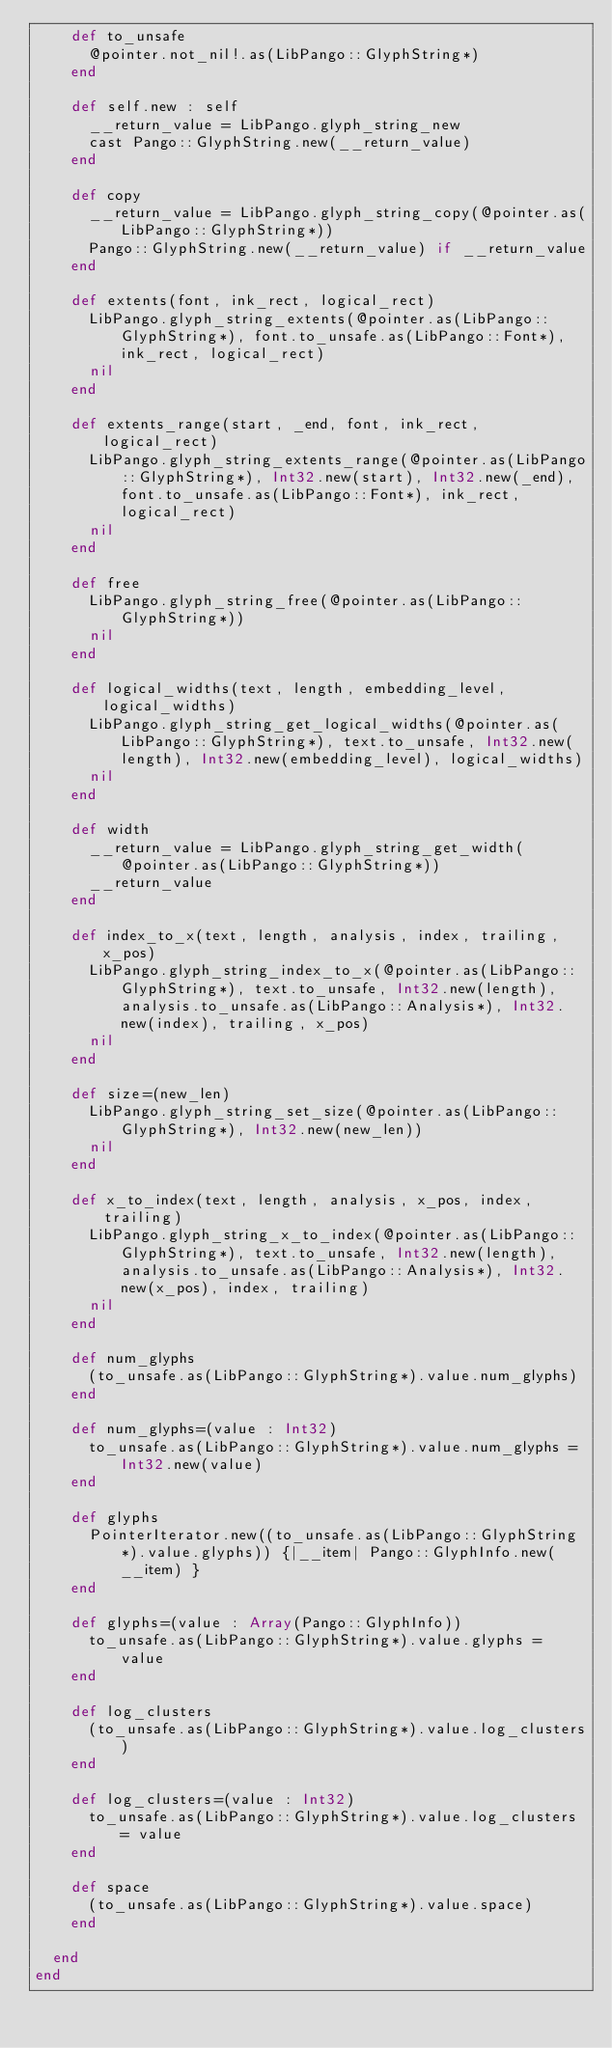Convert code to text. <code><loc_0><loc_0><loc_500><loc_500><_Crystal_>    def to_unsafe
      @pointer.not_nil!.as(LibPango::GlyphString*)
    end

    def self.new : self
      __return_value = LibPango.glyph_string_new
      cast Pango::GlyphString.new(__return_value)
    end

    def copy
      __return_value = LibPango.glyph_string_copy(@pointer.as(LibPango::GlyphString*))
      Pango::GlyphString.new(__return_value) if __return_value
    end

    def extents(font, ink_rect, logical_rect)
      LibPango.glyph_string_extents(@pointer.as(LibPango::GlyphString*), font.to_unsafe.as(LibPango::Font*), ink_rect, logical_rect)
      nil
    end

    def extents_range(start, _end, font, ink_rect, logical_rect)
      LibPango.glyph_string_extents_range(@pointer.as(LibPango::GlyphString*), Int32.new(start), Int32.new(_end), font.to_unsafe.as(LibPango::Font*), ink_rect, logical_rect)
      nil
    end

    def free
      LibPango.glyph_string_free(@pointer.as(LibPango::GlyphString*))
      nil
    end

    def logical_widths(text, length, embedding_level, logical_widths)
      LibPango.glyph_string_get_logical_widths(@pointer.as(LibPango::GlyphString*), text.to_unsafe, Int32.new(length), Int32.new(embedding_level), logical_widths)
      nil
    end

    def width
      __return_value = LibPango.glyph_string_get_width(@pointer.as(LibPango::GlyphString*))
      __return_value
    end

    def index_to_x(text, length, analysis, index, trailing, x_pos)
      LibPango.glyph_string_index_to_x(@pointer.as(LibPango::GlyphString*), text.to_unsafe, Int32.new(length), analysis.to_unsafe.as(LibPango::Analysis*), Int32.new(index), trailing, x_pos)
      nil
    end

    def size=(new_len)
      LibPango.glyph_string_set_size(@pointer.as(LibPango::GlyphString*), Int32.new(new_len))
      nil
    end

    def x_to_index(text, length, analysis, x_pos, index, trailing)
      LibPango.glyph_string_x_to_index(@pointer.as(LibPango::GlyphString*), text.to_unsafe, Int32.new(length), analysis.to_unsafe.as(LibPango::Analysis*), Int32.new(x_pos), index, trailing)
      nil
    end

    def num_glyphs
      (to_unsafe.as(LibPango::GlyphString*).value.num_glyphs)
    end

    def num_glyphs=(value : Int32)
      to_unsafe.as(LibPango::GlyphString*).value.num_glyphs = Int32.new(value)
    end

    def glyphs
      PointerIterator.new((to_unsafe.as(LibPango::GlyphString*).value.glyphs)) {|__item| Pango::GlyphInfo.new(__item) }
    end

    def glyphs=(value : Array(Pango::GlyphInfo))
      to_unsafe.as(LibPango::GlyphString*).value.glyphs = value
    end

    def log_clusters
      (to_unsafe.as(LibPango::GlyphString*).value.log_clusters)
    end

    def log_clusters=(value : Int32)
      to_unsafe.as(LibPango::GlyphString*).value.log_clusters = value
    end

    def space
      (to_unsafe.as(LibPango::GlyphString*).value.space)
    end

  end
end

</code> 